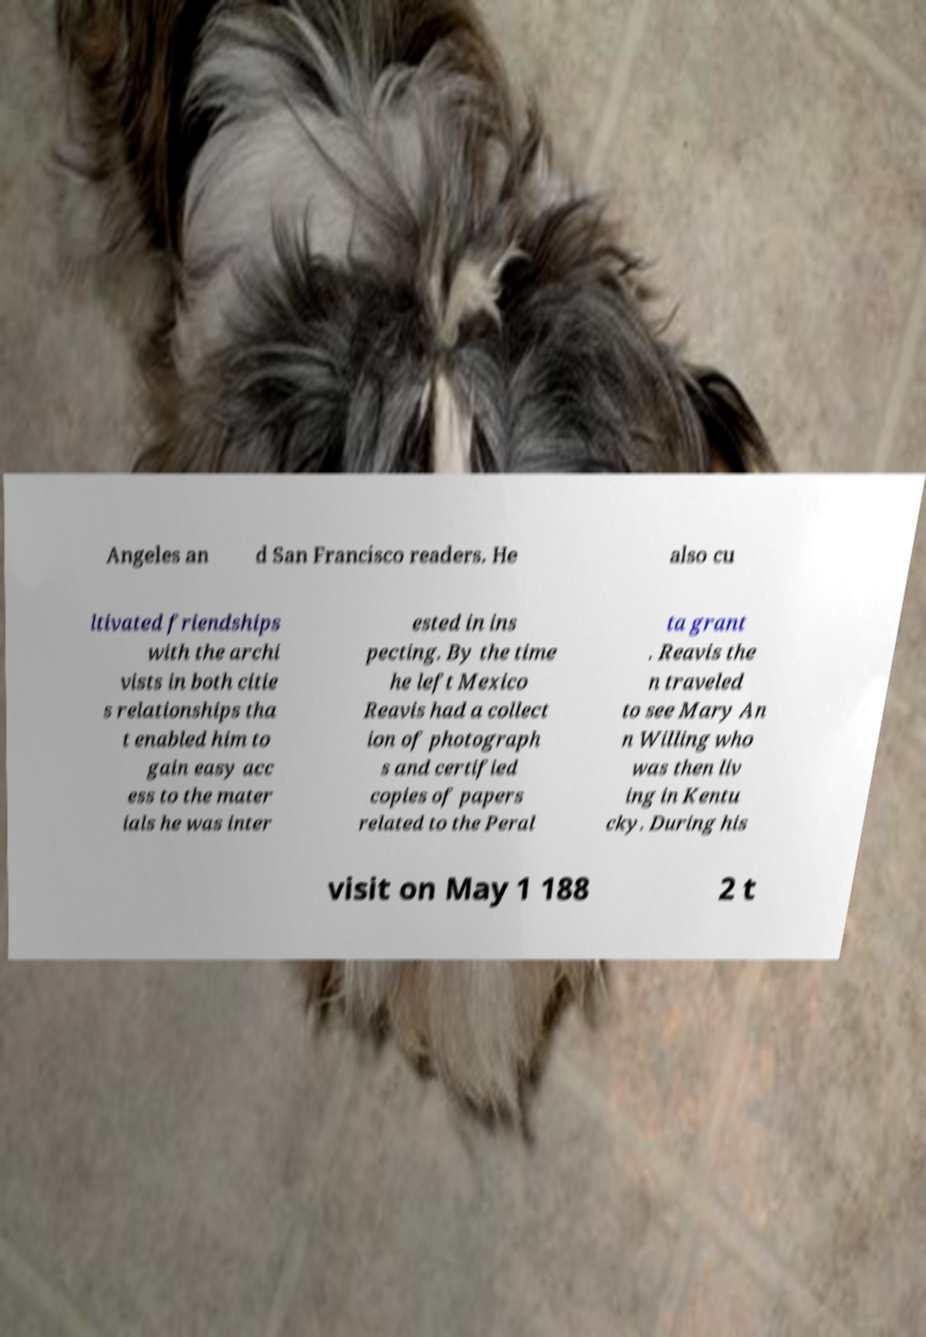For documentation purposes, I need the text within this image transcribed. Could you provide that? Angeles an d San Francisco readers. He also cu ltivated friendships with the archi vists in both citie s relationships tha t enabled him to gain easy acc ess to the mater ials he was inter ested in ins pecting. By the time he left Mexico Reavis had a collect ion of photograph s and certified copies of papers related to the Peral ta grant . Reavis the n traveled to see Mary An n Willing who was then liv ing in Kentu cky. During his visit on May 1 188 2 t 